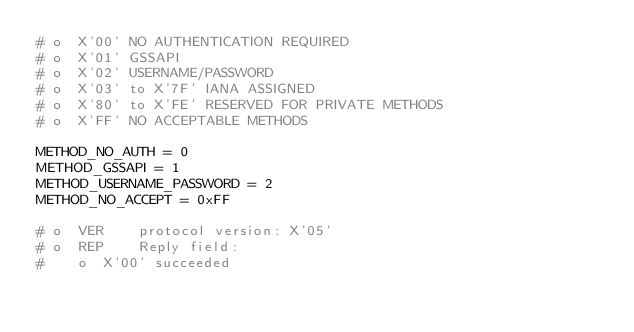Convert code to text. <code><loc_0><loc_0><loc_500><loc_500><_Python_># o  X'00' NO AUTHENTICATION REQUIRED
# o  X'01' GSSAPI
# o  X'02' USERNAME/PASSWORD
# o  X'03' to X'7F' IANA ASSIGNED
# o  X'80' to X'FE' RESERVED FOR PRIVATE METHODS
# o  X'FF' NO ACCEPTABLE METHODS

METHOD_NO_AUTH = 0
METHOD_GSSAPI = 1
METHOD_USERNAME_PASSWORD = 2
METHOD_NO_ACCEPT = 0xFF

# o  VER    protocol version: X'05'
# o  REP    Reply field:
#    o  X'00' succeeded</code> 